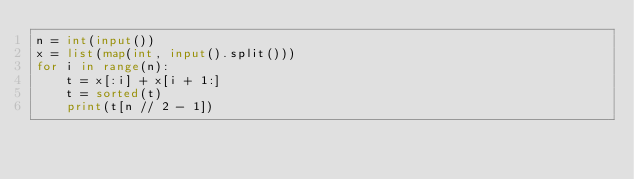Convert code to text. <code><loc_0><loc_0><loc_500><loc_500><_Python_>n = int(input())
x = list(map(int, input().split()))
for i in range(n):
    t = x[:i] + x[i + 1:]
    t = sorted(t)
    print(t[n // 2 - 1])</code> 